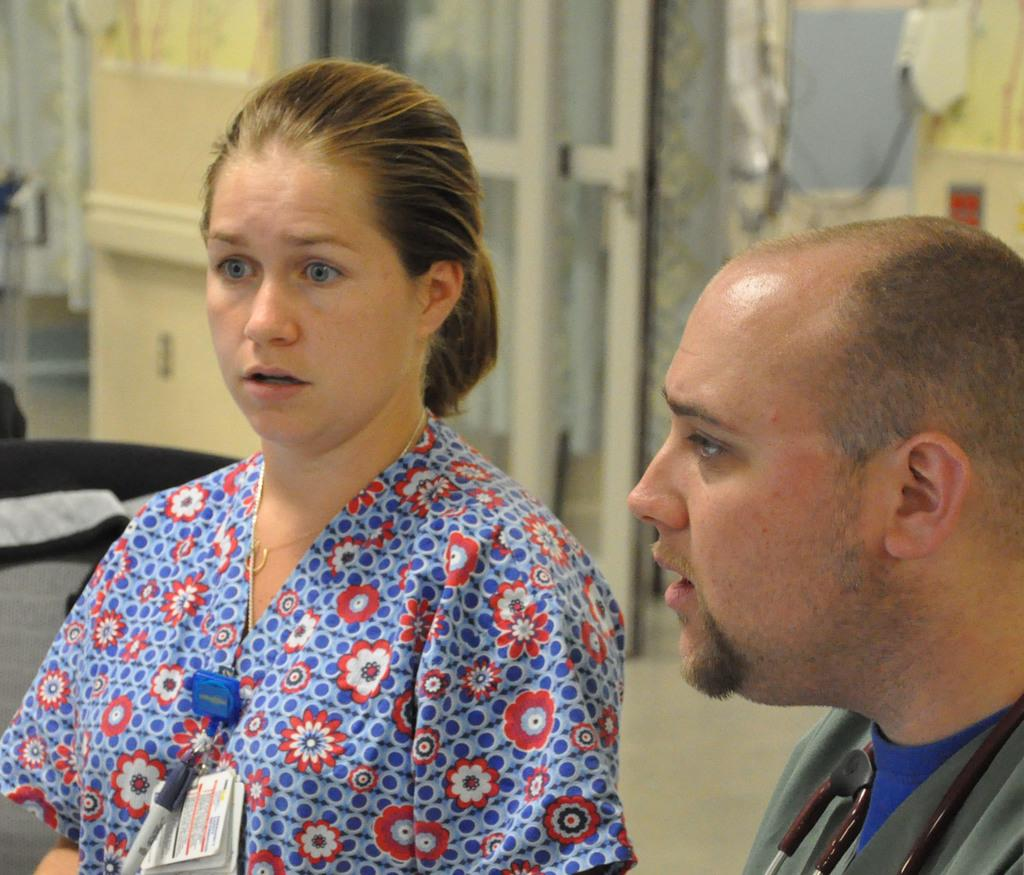How many people are in the image? There are two people in the image, a man and a woman. What are the man and woman wearing? The man and woman are both wearing clothes. What is the price of the cub in the image? There is no cub present in the image, so it is not possible to determine its price. 